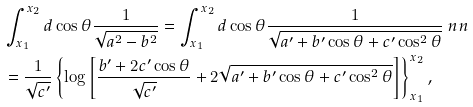<formula> <loc_0><loc_0><loc_500><loc_500>& \int _ { x _ { 1 } } ^ { x _ { 2 } } d \cos \theta \frac { 1 } { \sqrt { a ^ { 2 } - b ^ { 2 } } } = \int _ { x _ { 1 } } ^ { x _ { 2 } } d \cos \theta \frac { 1 } { \sqrt { a ^ { \prime } + b ^ { \prime } \cos \theta + c ^ { \prime } \cos ^ { 2 } \theta } } \ n n \\ & = \frac { 1 } { \sqrt { c ^ { \prime } } } \left \{ \log \left [ \frac { b ^ { \prime } + 2 c ^ { \prime } \cos \theta } { \sqrt { c ^ { \prime } } } + 2 \sqrt { a ^ { \prime } + b ^ { \prime } \cos \theta + c ^ { \prime } \cos ^ { 2 } \theta } \right ] \right \} _ { x _ { 1 } } ^ { x _ { 2 } } ,</formula> 